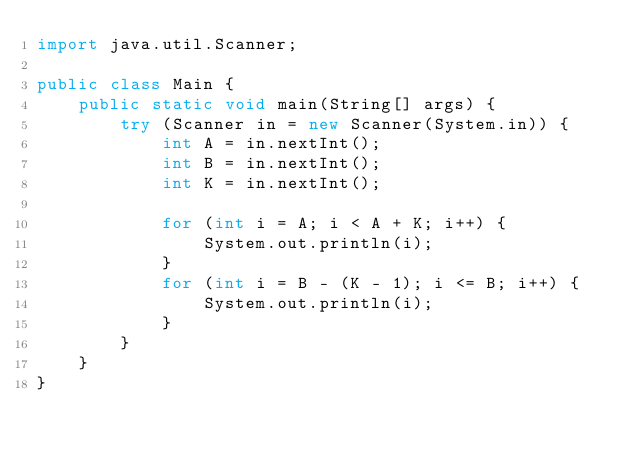<code> <loc_0><loc_0><loc_500><loc_500><_Java_>import java.util.Scanner;

public class Main {
    public static void main(String[] args) {
        try (Scanner in = new Scanner(System.in)) {
            int A = in.nextInt();
            int B = in.nextInt();
            int K = in.nextInt();

            for (int i = A; i < A + K; i++) {
                System.out.println(i);
            }
            for (int i = B - (K - 1); i <= B; i++) {
                System.out.println(i);
            }
        }
    }
}
</code> 